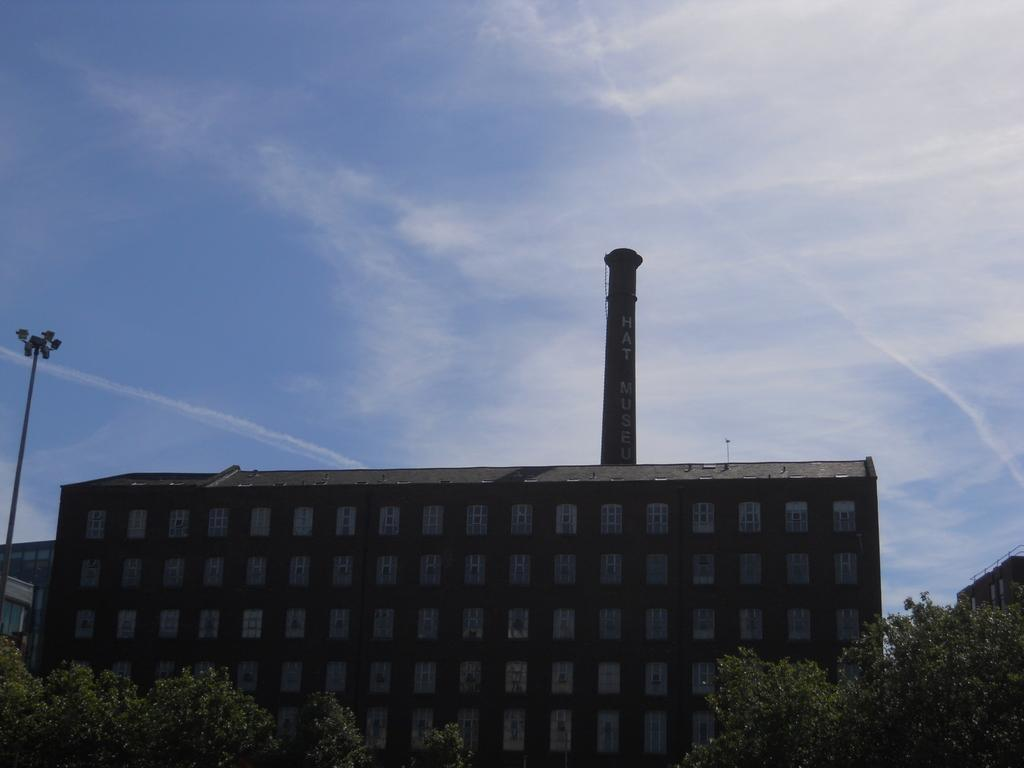What can be seen at the top of the image? The sky is visible in the image. What type of structure is in the image? There is a building in the image. What is located in front of the building? Trees are present in front of the building. Where is the pole located in the image? The pole is on the left side of the image. What type of prose is written on the pole in the image? There is no prose written on the pole in the image; it is just a pole. What type of frame is around the building in the image? There is no frame around the building in the image; it is just a building with trees in front of it. 